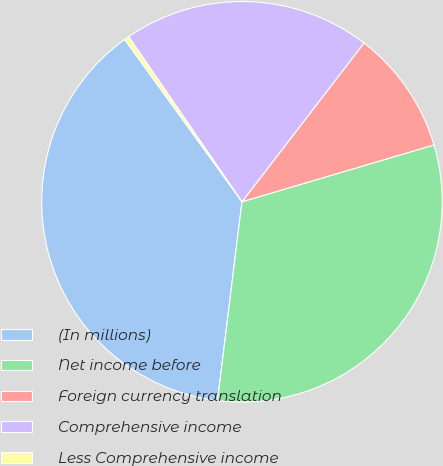Convert chart to OTSL. <chart><loc_0><loc_0><loc_500><loc_500><pie_chart><fcel>(In millions)<fcel>Net income before<fcel>Foreign currency translation<fcel>Comprehensive income<fcel>Less Comprehensive income<nl><fcel>38.1%<fcel>31.53%<fcel>9.99%<fcel>20.01%<fcel>0.38%<nl></chart> 